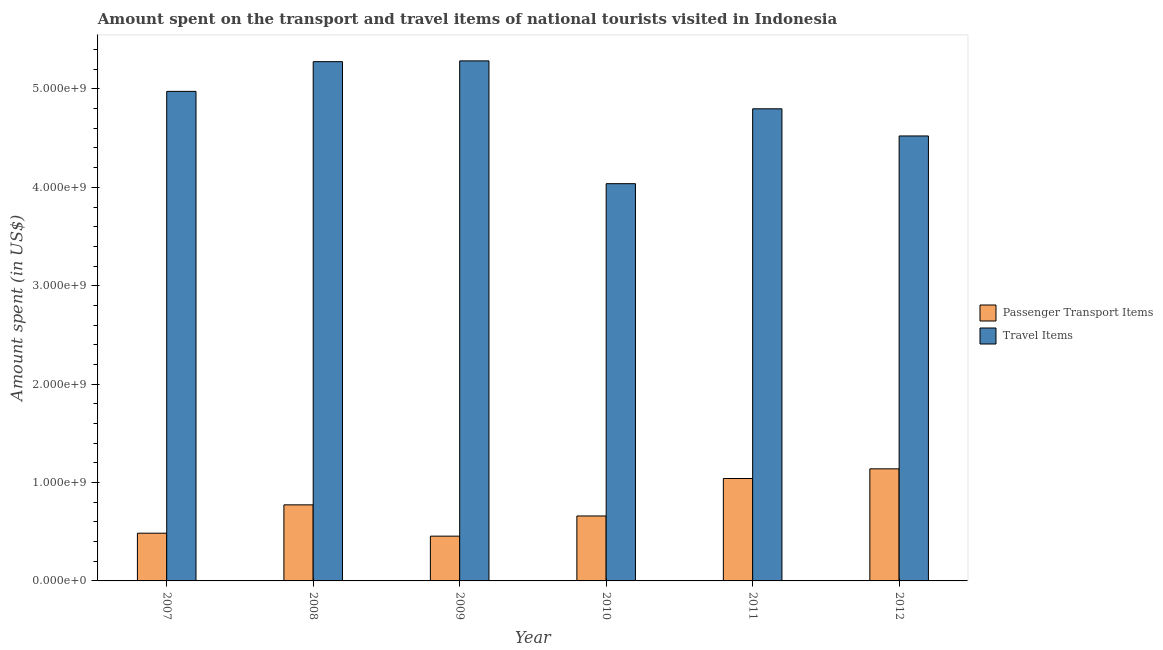Are the number of bars on each tick of the X-axis equal?
Keep it short and to the point. Yes. How many bars are there on the 2nd tick from the right?
Offer a very short reply. 2. What is the label of the 4th group of bars from the left?
Keep it short and to the point. 2010. What is the amount spent in travel items in 2012?
Your response must be concise. 4.52e+09. Across all years, what is the maximum amount spent on passenger transport items?
Provide a short and direct response. 1.14e+09. Across all years, what is the minimum amount spent on passenger transport items?
Ensure brevity in your answer.  4.55e+08. In which year was the amount spent in travel items minimum?
Provide a short and direct response. 2010. What is the total amount spent in travel items in the graph?
Offer a terse response. 2.89e+1. What is the difference between the amount spent in travel items in 2007 and that in 2012?
Ensure brevity in your answer.  4.53e+08. What is the difference between the amount spent in travel items in 2012 and the amount spent on passenger transport items in 2010?
Your answer should be very brief. 4.85e+08. What is the average amount spent in travel items per year?
Ensure brevity in your answer.  4.82e+09. In how many years, is the amount spent on passenger transport items greater than 5000000000 US$?
Ensure brevity in your answer.  0. What is the ratio of the amount spent on passenger transport items in 2009 to that in 2012?
Provide a short and direct response. 0.4. Is the difference between the amount spent in travel items in 2009 and 2010 greater than the difference between the amount spent on passenger transport items in 2009 and 2010?
Ensure brevity in your answer.  No. What is the difference between the highest and the second highest amount spent on passenger transport items?
Make the answer very short. 9.80e+07. What is the difference between the highest and the lowest amount spent on passenger transport items?
Ensure brevity in your answer.  6.84e+08. Is the sum of the amount spent on passenger transport items in 2009 and 2011 greater than the maximum amount spent in travel items across all years?
Give a very brief answer. Yes. What does the 2nd bar from the left in 2008 represents?
Your answer should be compact. Travel Items. What does the 1st bar from the right in 2011 represents?
Provide a succinct answer. Travel Items. How many bars are there?
Keep it short and to the point. 12. Are all the bars in the graph horizontal?
Provide a succinct answer. No. What is the difference between two consecutive major ticks on the Y-axis?
Provide a short and direct response. 1.00e+09. Are the values on the major ticks of Y-axis written in scientific E-notation?
Your answer should be compact. Yes. Does the graph contain any zero values?
Your answer should be very brief. No. How are the legend labels stacked?
Your answer should be compact. Vertical. What is the title of the graph?
Offer a very short reply. Amount spent on the transport and travel items of national tourists visited in Indonesia. Does "Fixed telephone" appear as one of the legend labels in the graph?
Offer a very short reply. No. What is the label or title of the X-axis?
Your response must be concise. Year. What is the label or title of the Y-axis?
Offer a very short reply. Amount spent (in US$). What is the Amount spent (in US$) in Passenger Transport Items in 2007?
Your answer should be compact. 4.85e+08. What is the Amount spent (in US$) in Travel Items in 2007?
Make the answer very short. 4.98e+09. What is the Amount spent (in US$) in Passenger Transport Items in 2008?
Provide a succinct answer. 7.73e+08. What is the Amount spent (in US$) of Travel Items in 2008?
Provide a succinct answer. 5.28e+09. What is the Amount spent (in US$) in Passenger Transport Items in 2009?
Your answer should be very brief. 4.55e+08. What is the Amount spent (in US$) in Travel Items in 2009?
Keep it short and to the point. 5.28e+09. What is the Amount spent (in US$) of Passenger Transport Items in 2010?
Offer a very short reply. 6.60e+08. What is the Amount spent (in US$) in Travel Items in 2010?
Your answer should be compact. 4.04e+09. What is the Amount spent (in US$) in Passenger Transport Items in 2011?
Your response must be concise. 1.04e+09. What is the Amount spent (in US$) of Travel Items in 2011?
Your answer should be compact. 4.80e+09. What is the Amount spent (in US$) in Passenger Transport Items in 2012?
Your answer should be very brief. 1.14e+09. What is the Amount spent (in US$) of Travel Items in 2012?
Provide a short and direct response. 4.52e+09. Across all years, what is the maximum Amount spent (in US$) in Passenger Transport Items?
Give a very brief answer. 1.14e+09. Across all years, what is the maximum Amount spent (in US$) in Travel Items?
Your answer should be compact. 5.28e+09. Across all years, what is the minimum Amount spent (in US$) of Passenger Transport Items?
Offer a terse response. 4.55e+08. Across all years, what is the minimum Amount spent (in US$) in Travel Items?
Offer a very short reply. 4.04e+09. What is the total Amount spent (in US$) of Passenger Transport Items in the graph?
Your response must be concise. 4.55e+09. What is the total Amount spent (in US$) of Travel Items in the graph?
Ensure brevity in your answer.  2.89e+1. What is the difference between the Amount spent (in US$) of Passenger Transport Items in 2007 and that in 2008?
Keep it short and to the point. -2.88e+08. What is the difference between the Amount spent (in US$) in Travel Items in 2007 and that in 2008?
Ensure brevity in your answer.  -3.02e+08. What is the difference between the Amount spent (in US$) in Passenger Transport Items in 2007 and that in 2009?
Your answer should be very brief. 3.00e+07. What is the difference between the Amount spent (in US$) in Travel Items in 2007 and that in 2009?
Your response must be concise. -3.10e+08. What is the difference between the Amount spent (in US$) of Passenger Transport Items in 2007 and that in 2010?
Provide a short and direct response. -1.75e+08. What is the difference between the Amount spent (in US$) in Travel Items in 2007 and that in 2010?
Make the answer very short. 9.38e+08. What is the difference between the Amount spent (in US$) of Passenger Transport Items in 2007 and that in 2011?
Offer a very short reply. -5.56e+08. What is the difference between the Amount spent (in US$) in Travel Items in 2007 and that in 2011?
Your response must be concise. 1.77e+08. What is the difference between the Amount spent (in US$) in Passenger Transport Items in 2007 and that in 2012?
Offer a terse response. -6.54e+08. What is the difference between the Amount spent (in US$) of Travel Items in 2007 and that in 2012?
Your response must be concise. 4.53e+08. What is the difference between the Amount spent (in US$) of Passenger Transport Items in 2008 and that in 2009?
Keep it short and to the point. 3.18e+08. What is the difference between the Amount spent (in US$) in Travel Items in 2008 and that in 2009?
Make the answer very short. -8.00e+06. What is the difference between the Amount spent (in US$) in Passenger Transport Items in 2008 and that in 2010?
Your answer should be compact. 1.13e+08. What is the difference between the Amount spent (in US$) in Travel Items in 2008 and that in 2010?
Ensure brevity in your answer.  1.24e+09. What is the difference between the Amount spent (in US$) in Passenger Transport Items in 2008 and that in 2011?
Your answer should be very brief. -2.68e+08. What is the difference between the Amount spent (in US$) of Travel Items in 2008 and that in 2011?
Ensure brevity in your answer.  4.79e+08. What is the difference between the Amount spent (in US$) in Passenger Transport Items in 2008 and that in 2012?
Offer a very short reply. -3.66e+08. What is the difference between the Amount spent (in US$) of Travel Items in 2008 and that in 2012?
Offer a very short reply. 7.55e+08. What is the difference between the Amount spent (in US$) of Passenger Transport Items in 2009 and that in 2010?
Provide a succinct answer. -2.05e+08. What is the difference between the Amount spent (in US$) in Travel Items in 2009 and that in 2010?
Provide a short and direct response. 1.25e+09. What is the difference between the Amount spent (in US$) in Passenger Transport Items in 2009 and that in 2011?
Keep it short and to the point. -5.86e+08. What is the difference between the Amount spent (in US$) of Travel Items in 2009 and that in 2011?
Make the answer very short. 4.87e+08. What is the difference between the Amount spent (in US$) in Passenger Transport Items in 2009 and that in 2012?
Offer a very short reply. -6.84e+08. What is the difference between the Amount spent (in US$) in Travel Items in 2009 and that in 2012?
Ensure brevity in your answer.  7.63e+08. What is the difference between the Amount spent (in US$) in Passenger Transport Items in 2010 and that in 2011?
Make the answer very short. -3.81e+08. What is the difference between the Amount spent (in US$) of Travel Items in 2010 and that in 2011?
Offer a very short reply. -7.61e+08. What is the difference between the Amount spent (in US$) of Passenger Transport Items in 2010 and that in 2012?
Keep it short and to the point. -4.79e+08. What is the difference between the Amount spent (in US$) of Travel Items in 2010 and that in 2012?
Ensure brevity in your answer.  -4.85e+08. What is the difference between the Amount spent (in US$) in Passenger Transport Items in 2011 and that in 2012?
Offer a terse response. -9.80e+07. What is the difference between the Amount spent (in US$) of Travel Items in 2011 and that in 2012?
Keep it short and to the point. 2.76e+08. What is the difference between the Amount spent (in US$) of Passenger Transport Items in 2007 and the Amount spent (in US$) of Travel Items in 2008?
Provide a succinct answer. -4.79e+09. What is the difference between the Amount spent (in US$) in Passenger Transport Items in 2007 and the Amount spent (in US$) in Travel Items in 2009?
Keep it short and to the point. -4.80e+09. What is the difference between the Amount spent (in US$) of Passenger Transport Items in 2007 and the Amount spent (in US$) of Travel Items in 2010?
Offer a terse response. -3.55e+09. What is the difference between the Amount spent (in US$) in Passenger Transport Items in 2007 and the Amount spent (in US$) in Travel Items in 2011?
Provide a succinct answer. -4.31e+09. What is the difference between the Amount spent (in US$) of Passenger Transport Items in 2007 and the Amount spent (in US$) of Travel Items in 2012?
Give a very brief answer. -4.04e+09. What is the difference between the Amount spent (in US$) in Passenger Transport Items in 2008 and the Amount spent (in US$) in Travel Items in 2009?
Ensure brevity in your answer.  -4.51e+09. What is the difference between the Amount spent (in US$) in Passenger Transport Items in 2008 and the Amount spent (in US$) in Travel Items in 2010?
Provide a short and direct response. -3.26e+09. What is the difference between the Amount spent (in US$) in Passenger Transport Items in 2008 and the Amount spent (in US$) in Travel Items in 2011?
Ensure brevity in your answer.  -4.02e+09. What is the difference between the Amount spent (in US$) in Passenger Transport Items in 2008 and the Amount spent (in US$) in Travel Items in 2012?
Provide a short and direct response. -3.75e+09. What is the difference between the Amount spent (in US$) of Passenger Transport Items in 2009 and the Amount spent (in US$) of Travel Items in 2010?
Provide a succinct answer. -3.58e+09. What is the difference between the Amount spent (in US$) of Passenger Transport Items in 2009 and the Amount spent (in US$) of Travel Items in 2011?
Make the answer very short. -4.34e+09. What is the difference between the Amount spent (in US$) in Passenger Transport Items in 2009 and the Amount spent (in US$) in Travel Items in 2012?
Provide a short and direct response. -4.07e+09. What is the difference between the Amount spent (in US$) in Passenger Transport Items in 2010 and the Amount spent (in US$) in Travel Items in 2011?
Provide a short and direct response. -4.14e+09. What is the difference between the Amount spent (in US$) of Passenger Transport Items in 2010 and the Amount spent (in US$) of Travel Items in 2012?
Provide a succinct answer. -3.86e+09. What is the difference between the Amount spent (in US$) in Passenger Transport Items in 2011 and the Amount spent (in US$) in Travel Items in 2012?
Provide a succinct answer. -3.48e+09. What is the average Amount spent (in US$) in Passenger Transport Items per year?
Offer a very short reply. 7.59e+08. What is the average Amount spent (in US$) in Travel Items per year?
Provide a succinct answer. 4.82e+09. In the year 2007, what is the difference between the Amount spent (in US$) in Passenger Transport Items and Amount spent (in US$) in Travel Items?
Make the answer very short. -4.49e+09. In the year 2008, what is the difference between the Amount spent (in US$) in Passenger Transport Items and Amount spent (in US$) in Travel Items?
Provide a succinct answer. -4.50e+09. In the year 2009, what is the difference between the Amount spent (in US$) of Passenger Transport Items and Amount spent (in US$) of Travel Items?
Your response must be concise. -4.83e+09. In the year 2010, what is the difference between the Amount spent (in US$) of Passenger Transport Items and Amount spent (in US$) of Travel Items?
Provide a short and direct response. -3.38e+09. In the year 2011, what is the difference between the Amount spent (in US$) in Passenger Transport Items and Amount spent (in US$) in Travel Items?
Ensure brevity in your answer.  -3.76e+09. In the year 2012, what is the difference between the Amount spent (in US$) in Passenger Transport Items and Amount spent (in US$) in Travel Items?
Your response must be concise. -3.38e+09. What is the ratio of the Amount spent (in US$) in Passenger Transport Items in 2007 to that in 2008?
Give a very brief answer. 0.63. What is the ratio of the Amount spent (in US$) of Travel Items in 2007 to that in 2008?
Offer a very short reply. 0.94. What is the ratio of the Amount spent (in US$) in Passenger Transport Items in 2007 to that in 2009?
Offer a very short reply. 1.07. What is the ratio of the Amount spent (in US$) of Travel Items in 2007 to that in 2009?
Keep it short and to the point. 0.94. What is the ratio of the Amount spent (in US$) of Passenger Transport Items in 2007 to that in 2010?
Provide a short and direct response. 0.73. What is the ratio of the Amount spent (in US$) of Travel Items in 2007 to that in 2010?
Make the answer very short. 1.23. What is the ratio of the Amount spent (in US$) in Passenger Transport Items in 2007 to that in 2011?
Your response must be concise. 0.47. What is the ratio of the Amount spent (in US$) in Travel Items in 2007 to that in 2011?
Offer a terse response. 1.04. What is the ratio of the Amount spent (in US$) in Passenger Transport Items in 2007 to that in 2012?
Keep it short and to the point. 0.43. What is the ratio of the Amount spent (in US$) of Travel Items in 2007 to that in 2012?
Your response must be concise. 1.1. What is the ratio of the Amount spent (in US$) in Passenger Transport Items in 2008 to that in 2009?
Your response must be concise. 1.7. What is the ratio of the Amount spent (in US$) in Passenger Transport Items in 2008 to that in 2010?
Give a very brief answer. 1.17. What is the ratio of the Amount spent (in US$) in Travel Items in 2008 to that in 2010?
Keep it short and to the point. 1.31. What is the ratio of the Amount spent (in US$) of Passenger Transport Items in 2008 to that in 2011?
Provide a short and direct response. 0.74. What is the ratio of the Amount spent (in US$) in Travel Items in 2008 to that in 2011?
Provide a succinct answer. 1.1. What is the ratio of the Amount spent (in US$) in Passenger Transport Items in 2008 to that in 2012?
Provide a succinct answer. 0.68. What is the ratio of the Amount spent (in US$) of Travel Items in 2008 to that in 2012?
Offer a very short reply. 1.17. What is the ratio of the Amount spent (in US$) of Passenger Transport Items in 2009 to that in 2010?
Give a very brief answer. 0.69. What is the ratio of the Amount spent (in US$) in Travel Items in 2009 to that in 2010?
Provide a succinct answer. 1.31. What is the ratio of the Amount spent (in US$) in Passenger Transport Items in 2009 to that in 2011?
Keep it short and to the point. 0.44. What is the ratio of the Amount spent (in US$) in Travel Items in 2009 to that in 2011?
Offer a very short reply. 1.1. What is the ratio of the Amount spent (in US$) of Passenger Transport Items in 2009 to that in 2012?
Ensure brevity in your answer.  0.4. What is the ratio of the Amount spent (in US$) in Travel Items in 2009 to that in 2012?
Offer a very short reply. 1.17. What is the ratio of the Amount spent (in US$) of Passenger Transport Items in 2010 to that in 2011?
Ensure brevity in your answer.  0.63. What is the ratio of the Amount spent (in US$) in Travel Items in 2010 to that in 2011?
Provide a short and direct response. 0.84. What is the ratio of the Amount spent (in US$) of Passenger Transport Items in 2010 to that in 2012?
Your answer should be very brief. 0.58. What is the ratio of the Amount spent (in US$) in Travel Items in 2010 to that in 2012?
Offer a very short reply. 0.89. What is the ratio of the Amount spent (in US$) of Passenger Transport Items in 2011 to that in 2012?
Offer a terse response. 0.91. What is the ratio of the Amount spent (in US$) in Travel Items in 2011 to that in 2012?
Make the answer very short. 1.06. What is the difference between the highest and the second highest Amount spent (in US$) in Passenger Transport Items?
Give a very brief answer. 9.80e+07. What is the difference between the highest and the second highest Amount spent (in US$) of Travel Items?
Provide a succinct answer. 8.00e+06. What is the difference between the highest and the lowest Amount spent (in US$) in Passenger Transport Items?
Your answer should be compact. 6.84e+08. What is the difference between the highest and the lowest Amount spent (in US$) of Travel Items?
Your response must be concise. 1.25e+09. 